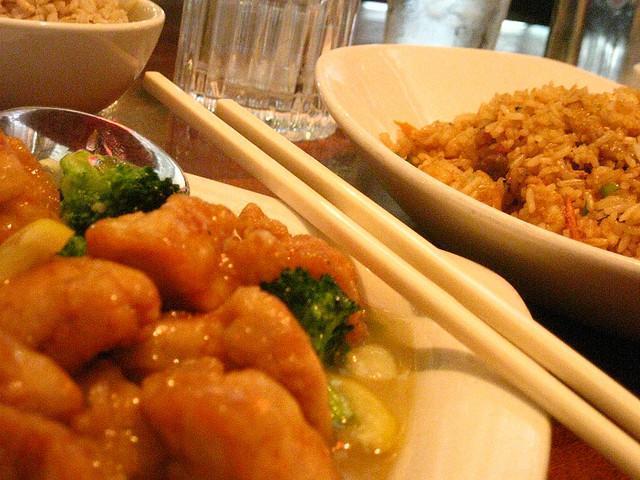How many cups are in the picture?
Give a very brief answer. 2. How many bowls can you see?
Give a very brief answer. 2. How many broccolis are in the picture?
Give a very brief answer. 2. 